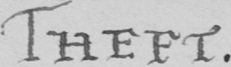Can you tell me what this handwritten text says? THEFT 